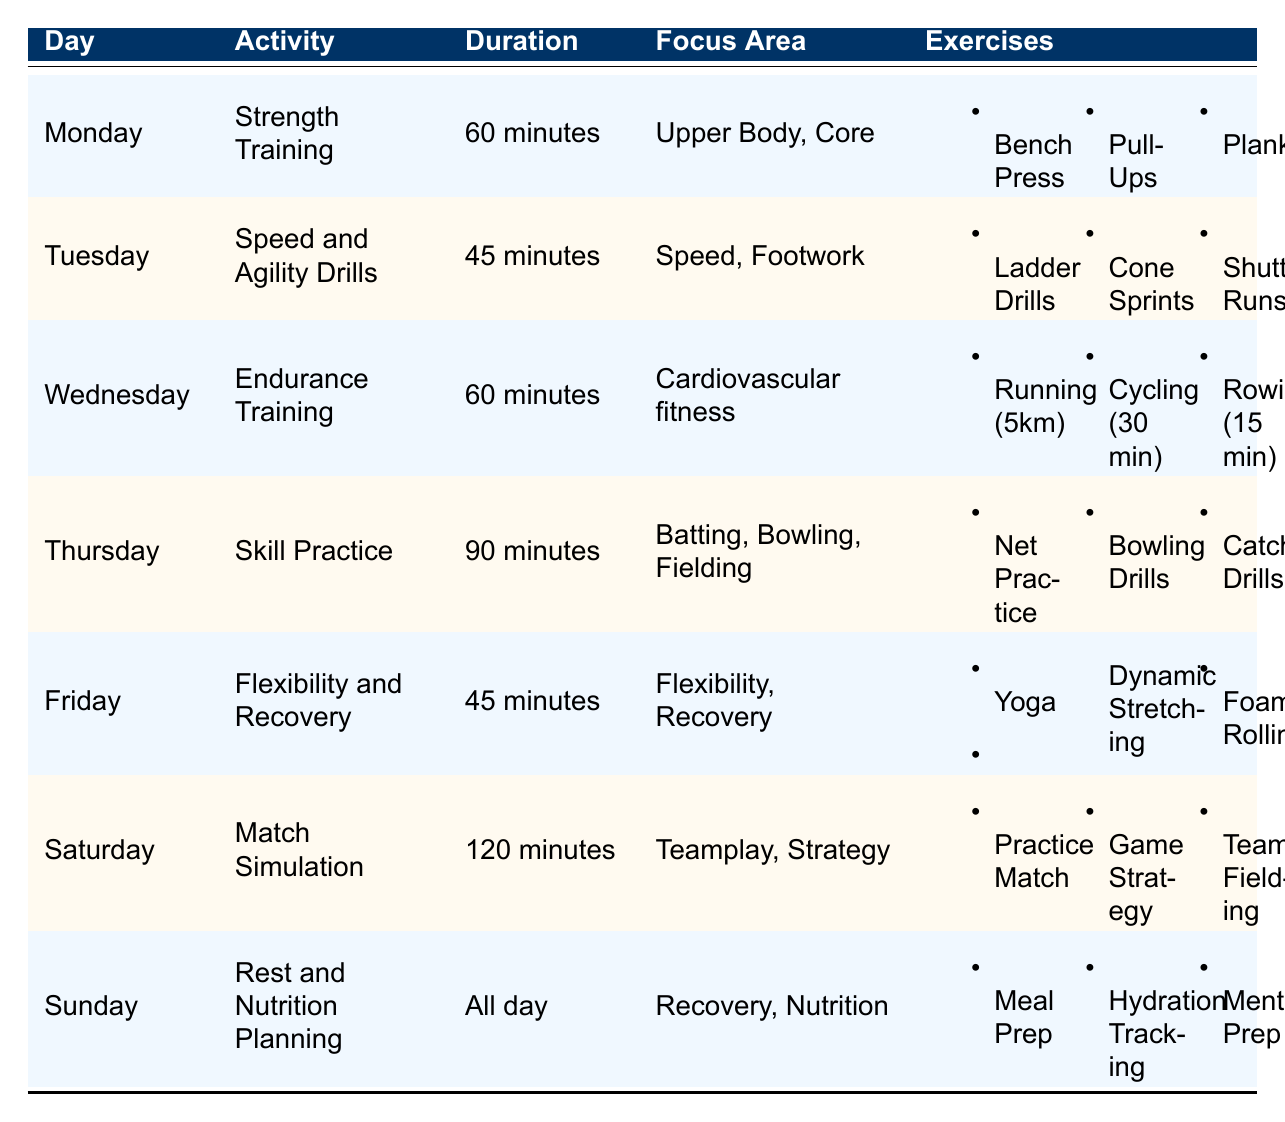What is the activity planned for Thursday? The table lists that on Thursday, the activity is "Skill Practice."
Answer: Skill Practice How long does the endurance training last? According to the table, endurance training lasts for "60 minutes."
Answer: 60 minutes What is the focus area of flexibility and recovery training? The table indicates that the focus area for flexibility and recovery training is "Flexibility, Recovery."
Answer: Flexibility, Recovery Which day includes match simulation as an activity? The table shows that "Match Simulation" is the activity scheduled for Saturday.
Answer: Saturday Are there any exercises for speed and agility drills? The table confirms that there are exercises listed for speed and agility drills, specifically: "Ladder Drills, Cone Sprints, Shuttle Runs."
Answer: Yes What is the total duration of activities from Monday to Friday? The durations for Monday to Friday are: 60 minutes (Monday) + 45 minutes (Tuesday) + 60 minutes (Wednesday) + 90 minutes (Thursday) + 45 minutes (Friday) = 300 minutes in total.
Answer: 300 minutes Is yoga included in the fitness regimen? The table indicates that yoga is included as an exercise for flexibility and recovery on Friday.
Answer: Yes How many different focus areas are targeted in the skills practice? From the table, skills practice targets three focus areas: "Batting, Bowling, Fielding." Thus, there are three different focus areas.
Answer: 3 What is the longest single activity duration in the schedule? The longest activity listed is "Match Simulation" on Saturday, which lasts for "120 minutes."
Answer: 120 minutes On which day is nutrition planning included in the agenda? The table states that "Rest and Nutrition Planning" is included on Sunday.
Answer: Sunday 